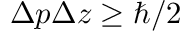Convert formula to latex. <formula><loc_0><loc_0><loc_500><loc_500>\Delta p \Delta z \geq \hbar { / } 2</formula> 